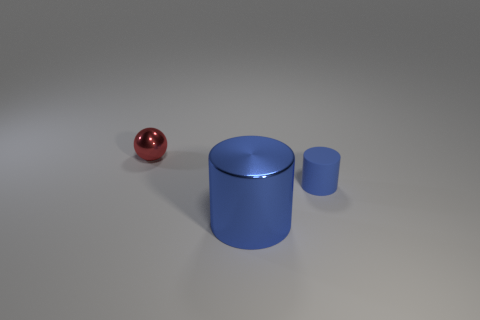Add 2 small cylinders. How many objects exist? 5 Subtract 0 brown cylinders. How many objects are left? 3 Subtract all cylinders. How many objects are left? 1 Subtract all big blue cylinders. Subtract all large cylinders. How many objects are left? 1 Add 1 shiny things. How many shiny things are left? 3 Add 1 blue metal cylinders. How many blue metal cylinders exist? 2 